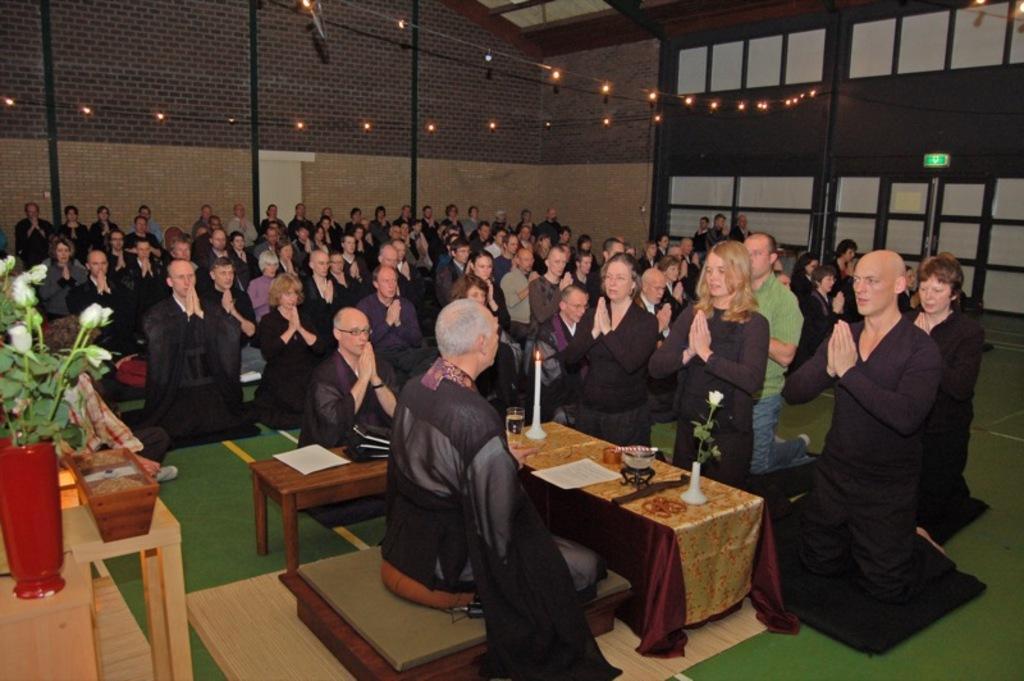Please provide a concise description of this image. In this picture we can see a person sitting and in front, there is candle, glass and flower and paper and some other objects on the table ,and and in front there are many people standing on the floor and praying, and at the top there are lights, and here there is a flower pot on the table. 